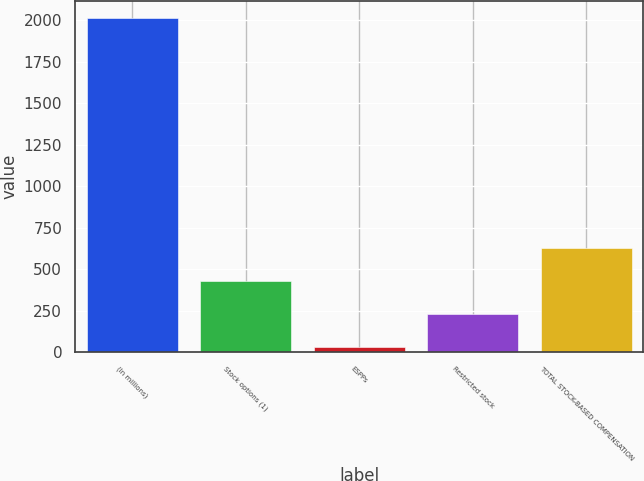Convert chart. <chart><loc_0><loc_0><loc_500><loc_500><bar_chart><fcel>(In millions)<fcel>Stock options (1)<fcel>ESPPs<fcel>Restricted stock<fcel>TOTAL STOCK-BASED COMPENSATION<nl><fcel>2016<fcel>428<fcel>31<fcel>229.5<fcel>626.5<nl></chart> 